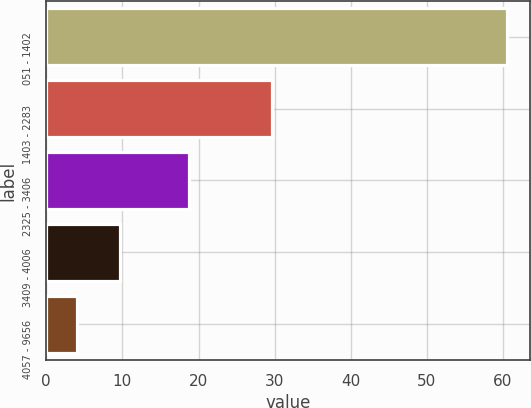Convert chart. <chart><loc_0><loc_0><loc_500><loc_500><bar_chart><fcel>051 - 1402<fcel>1403 - 2283<fcel>2325 - 3406<fcel>3409 - 4006<fcel>4057 - 9656<nl><fcel>60.5<fcel>29.6<fcel>18.8<fcel>9.65<fcel>4<nl></chart> 